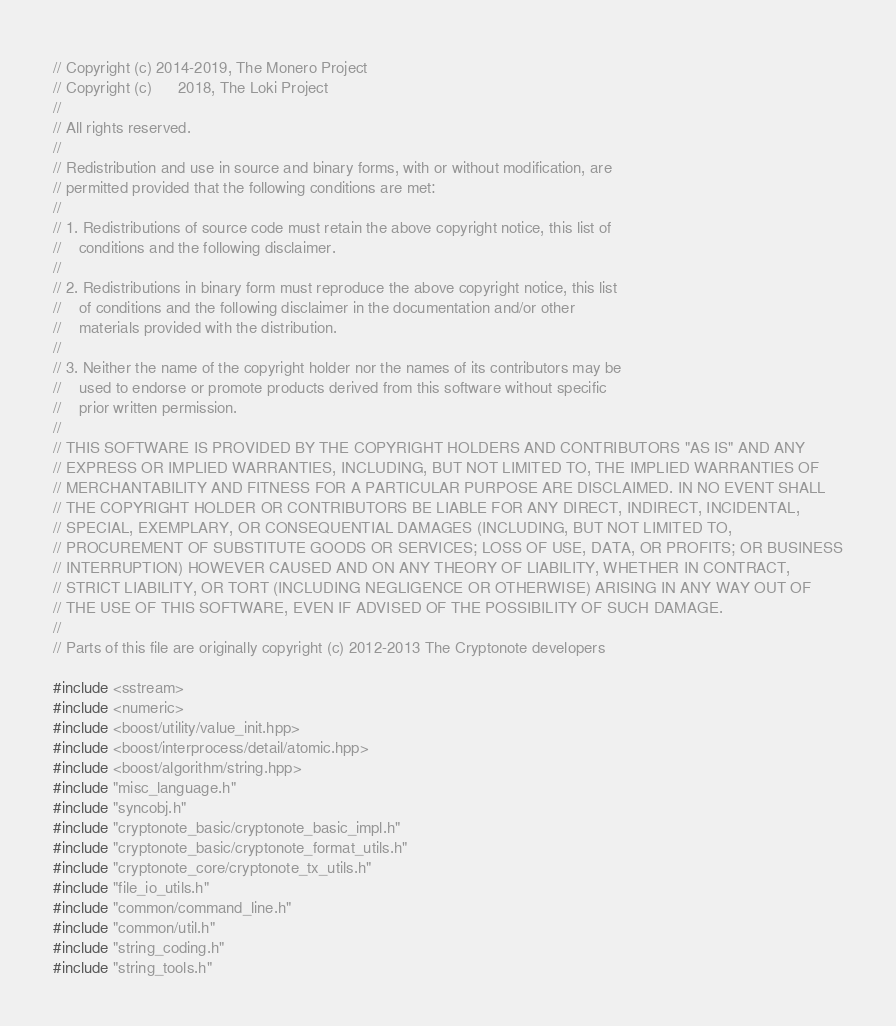<code> <loc_0><loc_0><loc_500><loc_500><_C++_>// Copyright (c) 2014-2019, The Monero Project
// Copyright (c)      2018, The Loki Project
//
// All rights reserved.
//
// Redistribution and use in source and binary forms, with or without modification, are
// permitted provided that the following conditions are met:
//
// 1. Redistributions of source code must retain the above copyright notice, this list of
//    conditions and the following disclaimer.
//
// 2. Redistributions in binary form must reproduce the above copyright notice, this list
//    of conditions and the following disclaimer in the documentation and/or other
//    materials provided with the distribution.
//
// 3. Neither the name of the copyright holder nor the names of its contributors may be
//    used to endorse or promote products derived from this software without specific
//    prior written permission.
//
// THIS SOFTWARE IS PROVIDED BY THE COPYRIGHT HOLDERS AND CONTRIBUTORS "AS IS" AND ANY
// EXPRESS OR IMPLIED WARRANTIES, INCLUDING, BUT NOT LIMITED TO, THE IMPLIED WARRANTIES OF
// MERCHANTABILITY AND FITNESS FOR A PARTICULAR PURPOSE ARE DISCLAIMED. IN NO EVENT SHALL
// THE COPYRIGHT HOLDER OR CONTRIBUTORS BE LIABLE FOR ANY DIRECT, INDIRECT, INCIDENTAL,
// SPECIAL, EXEMPLARY, OR CONSEQUENTIAL DAMAGES (INCLUDING, BUT NOT LIMITED TO,
// PROCUREMENT OF SUBSTITUTE GOODS OR SERVICES; LOSS OF USE, DATA, OR PROFITS; OR BUSINESS
// INTERRUPTION) HOWEVER CAUSED AND ON ANY THEORY OF LIABILITY, WHETHER IN CONTRACT,
// STRICT LIABILITY, OR TORT (INCLUDING NEGLIGENCE OR OTHERWISE) ARISING IN ANY WAY OUT OF
// THE USE OF THIS SOFTWARE, EVEN IF ADVISED OF THE POSSIBILITY OF SUCH DAMAGE.
//
// Parts of this file are originally copyright (c) 2012-2013 The Cryptonote developers

#include <sstream>
#include <numeric>
#include <boost/utility/value_init.hpp>
#include <boost/interprocess/detail/atomic.hpp>
#include <boost/algorithm/string.hpp>
#include "misc_language.h"
#include "syncobj.h"
#include "cryptonote_basic/cryptonote_basic_impl.h"
#include "cryptonote_basic/cryptonote_format_utils.h"
#include "cryptonote_core/cryptonote_tx_utils.h"
#include "file_io_utils.h"
#include "common/command_line.h"
#include "common/util.h"
#include "string_coding.h"
#include "string_tools.h"</code> 